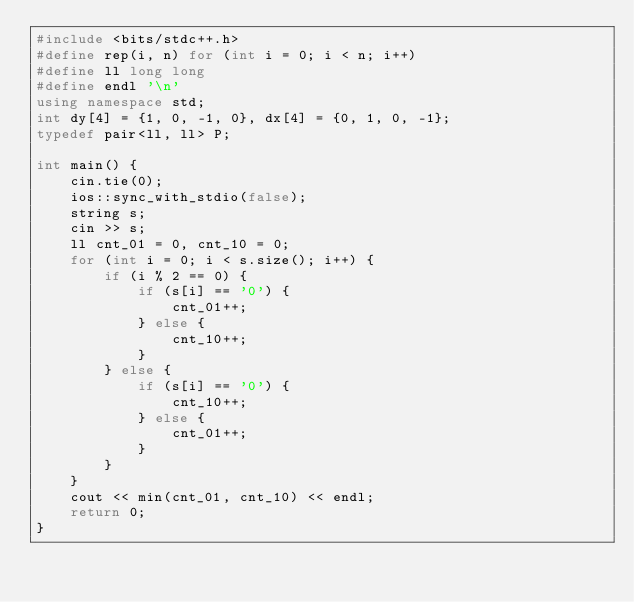Convert code to text. <code><loc_0><loc_0><loc_500><loc_500><_C++_>#include <bits/stdc++.h>
#define rep(i, n) for (int i = 0; i < n; i++)
#define ll long long
#define endl '\n'
using namespace std;
int dy[4] = {1, 0, -1, 0}, dx[4] = {0, 1, 0, -1};
typedef pair<ll, ll> P;

int main() {
    cin.tie(0);
    ios::sync_with_stdio(false);
    string s;
    cin >> s;
    ll cnt_01 = 0, cnt_10 = 0;
    for (int i = 0; i < s.size(); i++) {
        if (i % 2 == 0) {
            if (s[i] == '0') {
                cnt_01++;
            } else {
                cnt_10++;
            }
        } else {
            if (s[i] == '0') {
                cnt_10++;
            } else {
                cnt_01++;
            }
        }
    }
    cout << min(cnt_01, cnt_10) << endl;
    return 0;
}</code> 